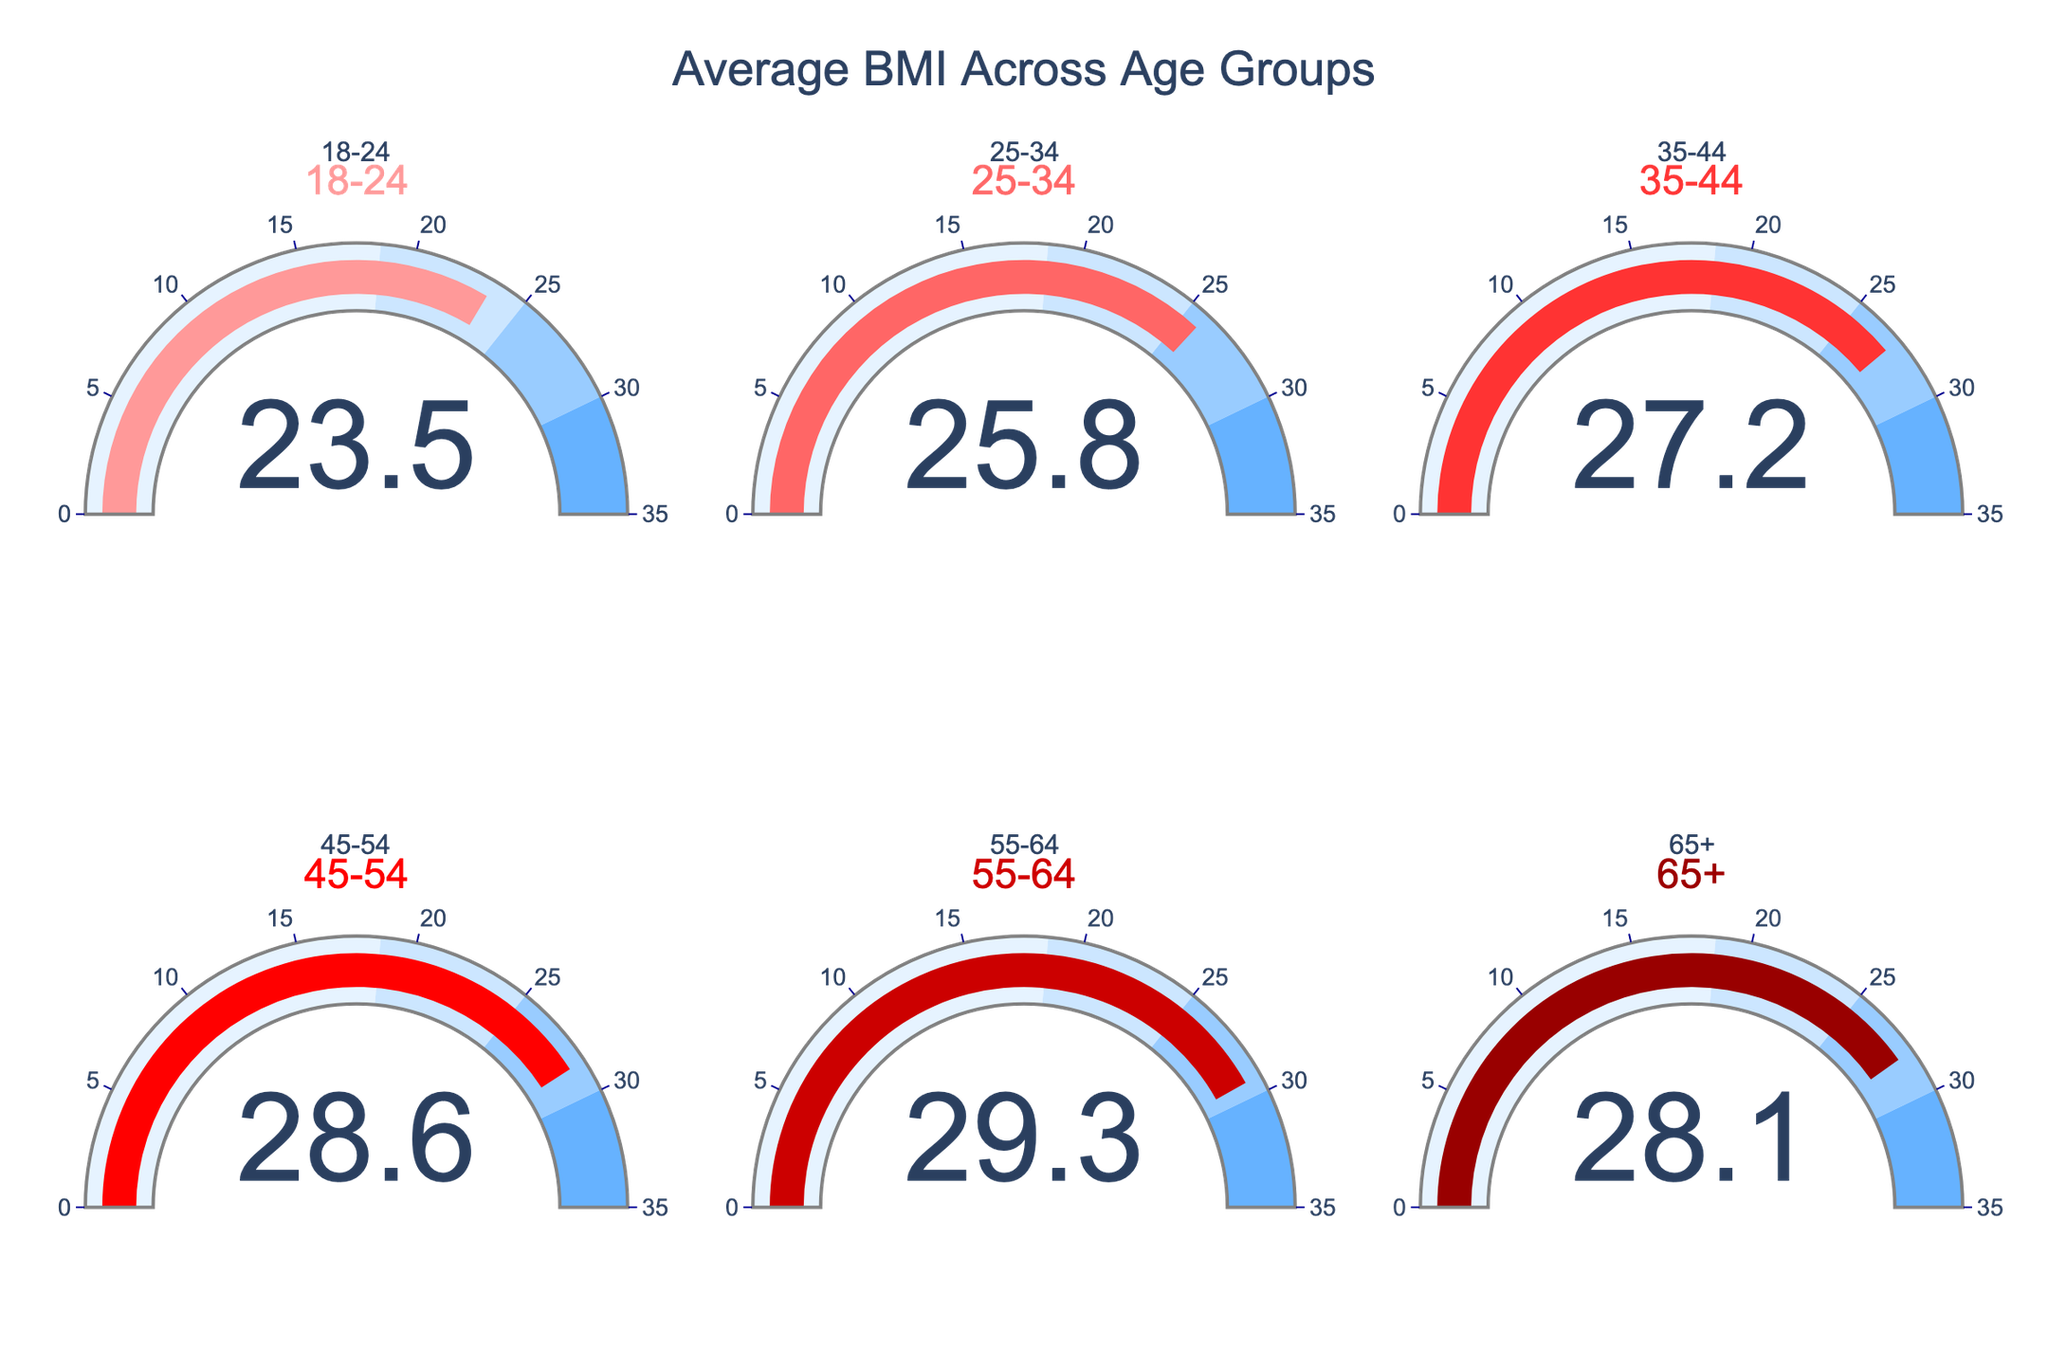What's the title of the figure? The title is displayed prominently at the top of the figure.
Answer: Average BMI Across Age Groups How many age groups are displayed in the figure? By counting the number of gauges, we see there are six age groups.
Answer: 6 Which age group has the highest average BMI? The gauge for the 55-64 age group shows the highest value among all the gauges.
Answer: 55-64 Which age group has the lowest average BMI? The gauge for the 18-24 age group shows the lowest value among all the gauges.
Answer: 18-24 What is the average BMI for the 25-34 age group? The value displayed on the gauge for the 25-34 age group is the average BMI for that group.
Answer: 25.8 Is the average BMI for the 45-54 age group greater than the average BMI for the 35-44 age group? The gauge for the 45-54 age group shows 28.6, which is higher than the 27.2 shown on the gauge for the 35-44 age group.
Answer: Yes What's the difference between the highest and lowest average BMI across all age groups? The highest average BMI is 29.3 for the 55-64 age group, and the lowest is 23.5 for the 18-24 age group. The difference is 29.3 - 23.5.
Answer: 5.8 What is the average BMI across all age groups? To calculate the average BMI across all groups, add the average BMIs and divide by the total number of groups. (23.5 + 25.8 + 27.2 + 28.6 + 29.3 + 28.1) / 6.
Answer: 27.08 How does the average BMI of the 65+ age group compare to the 35-44 age group? The average BMI of the 65+ age group is 28.1, which is slightly higher than the 27.2 of the 35-44 age group.
Answer: 65+ is higher Which age group falls into the range of 25 to 30 for their average BMI? The gauges for the 25-34, 35-44, 45-54, and 65+ age groups show average BMIs within the 25 to 30 range.
Answer: 25-34, 35-44, 45-54, 65+ 